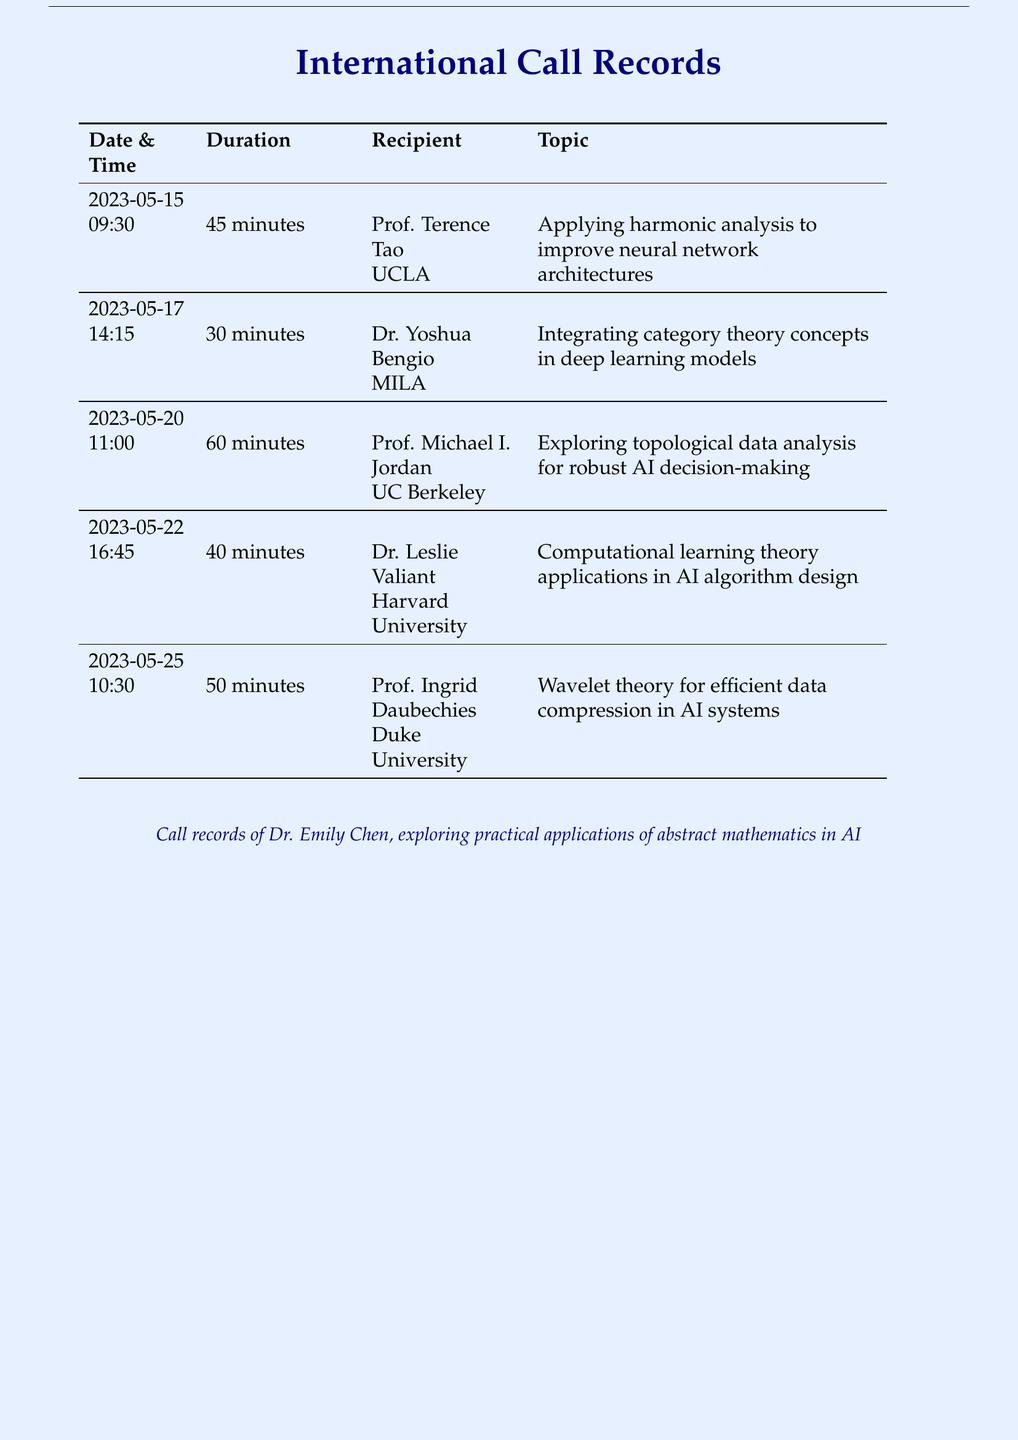What is the date of the call with Prof. Terence Tao? The call with Prof. Terence Tao took place on May 15, 2023.
Answer: May 15, 2023 How long was the call with Dr. Yoshua Bengio? The duration of the call with Dr. Yoshua Bengio was 30 minutes.
Answer: 30 minutes Who is the recipient of the call on May 22, 2023? The recipient of the call on May 22, 2023, was Dr. Leslie Valiant.
Answer: Dr. Leslie Valiant What topic was discussed with Prof. Michael I. Jordan? The topic discussed with Prof. Michael I. Jordan was exploring topological data analysis for robust AI decision-making.
Answer: Exploring topological data analysis for robust AI decision-making Which mathematician was consulted about wavelet theory? The mathematician consulted about wavelet theory was Prof. Ingrid Daubechies.
Answer: Prof. Ingrid Daubechies What is the total duration of all the calls listed? The total duration is the sum of the durations of all calls: 45 + 30 + 60 + 40 + 50 = 225 minutes.
Answer: 225 minutes How many calls were made to mathematicians? There were five calls made to mathematicians.
Answer: Five What is the primary focus of the calls listed in the document? The primary focus of the calls is exploring the practical applications of abstract mathematics in AI.
Answer: Applications of abstract mathematics in AI Which university does Prof. Terence Tao represent? Prof. Terence Tao represents UCLA.
Answer: UCLA 